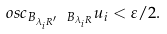<formula> <loc_0><loc_0><loc_500><loc_500>o s c _ { B _ { \lambda _ { i } R ^ { \prime } } \ B _ { \lambda _ { i } R } } u _ { i } < \varepsilon / 2 .</formula> 